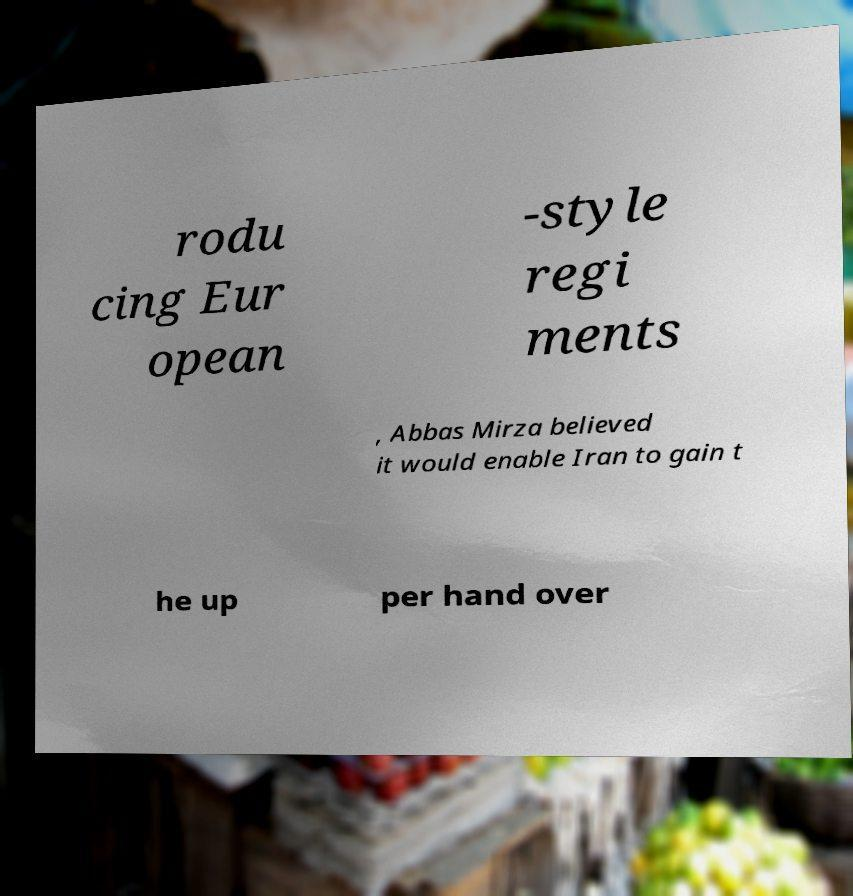Please read and relay the text visible in this image. What does it say? rodu cing Eur opean -style regi ments , Abbas Mirza believed it would enable Iran to gain t he up per hand over 